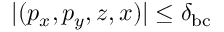<formula> <loc_0><loc_0><loc_500><loc_500>| ( p _ { x } , p _ { y } , z , x ) | \leq \delta _ { b c }</formula> 